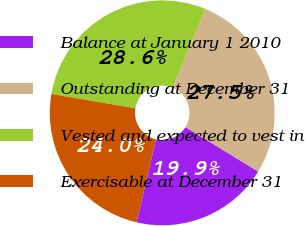Convert chart to OTSL. <chart><loc_0><loc_0><loc_500><loc_500><pie_chart><fcel>Balance at January 1 2010<fcel>Outstanding at December 31<fcel>Vested and expected to vest in<fcel>Exercisable at December 31<nl><fcel>19.94%<fcel>27.48%<fcel>28.58%<fcel>24.0%<nl></chart> 